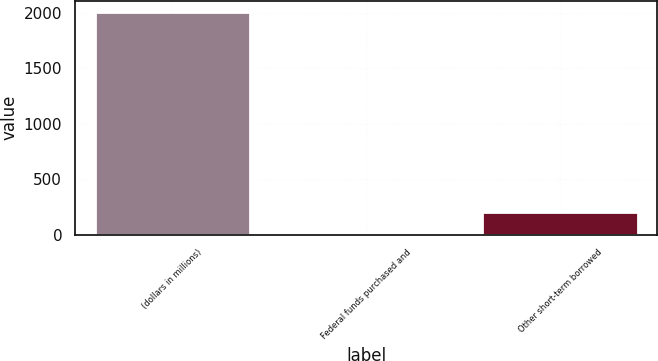Convert chart to OTSL. <chart><loc_0><loc_0><loc_500><loc_500><bar_chart><fcel>(dollars in millions)<fcel>Federal funds purchased and<fcel>Other short-term borrowed<nl><fcel>2012<fcel>0.1<fcel>201.29<nl></chart> 